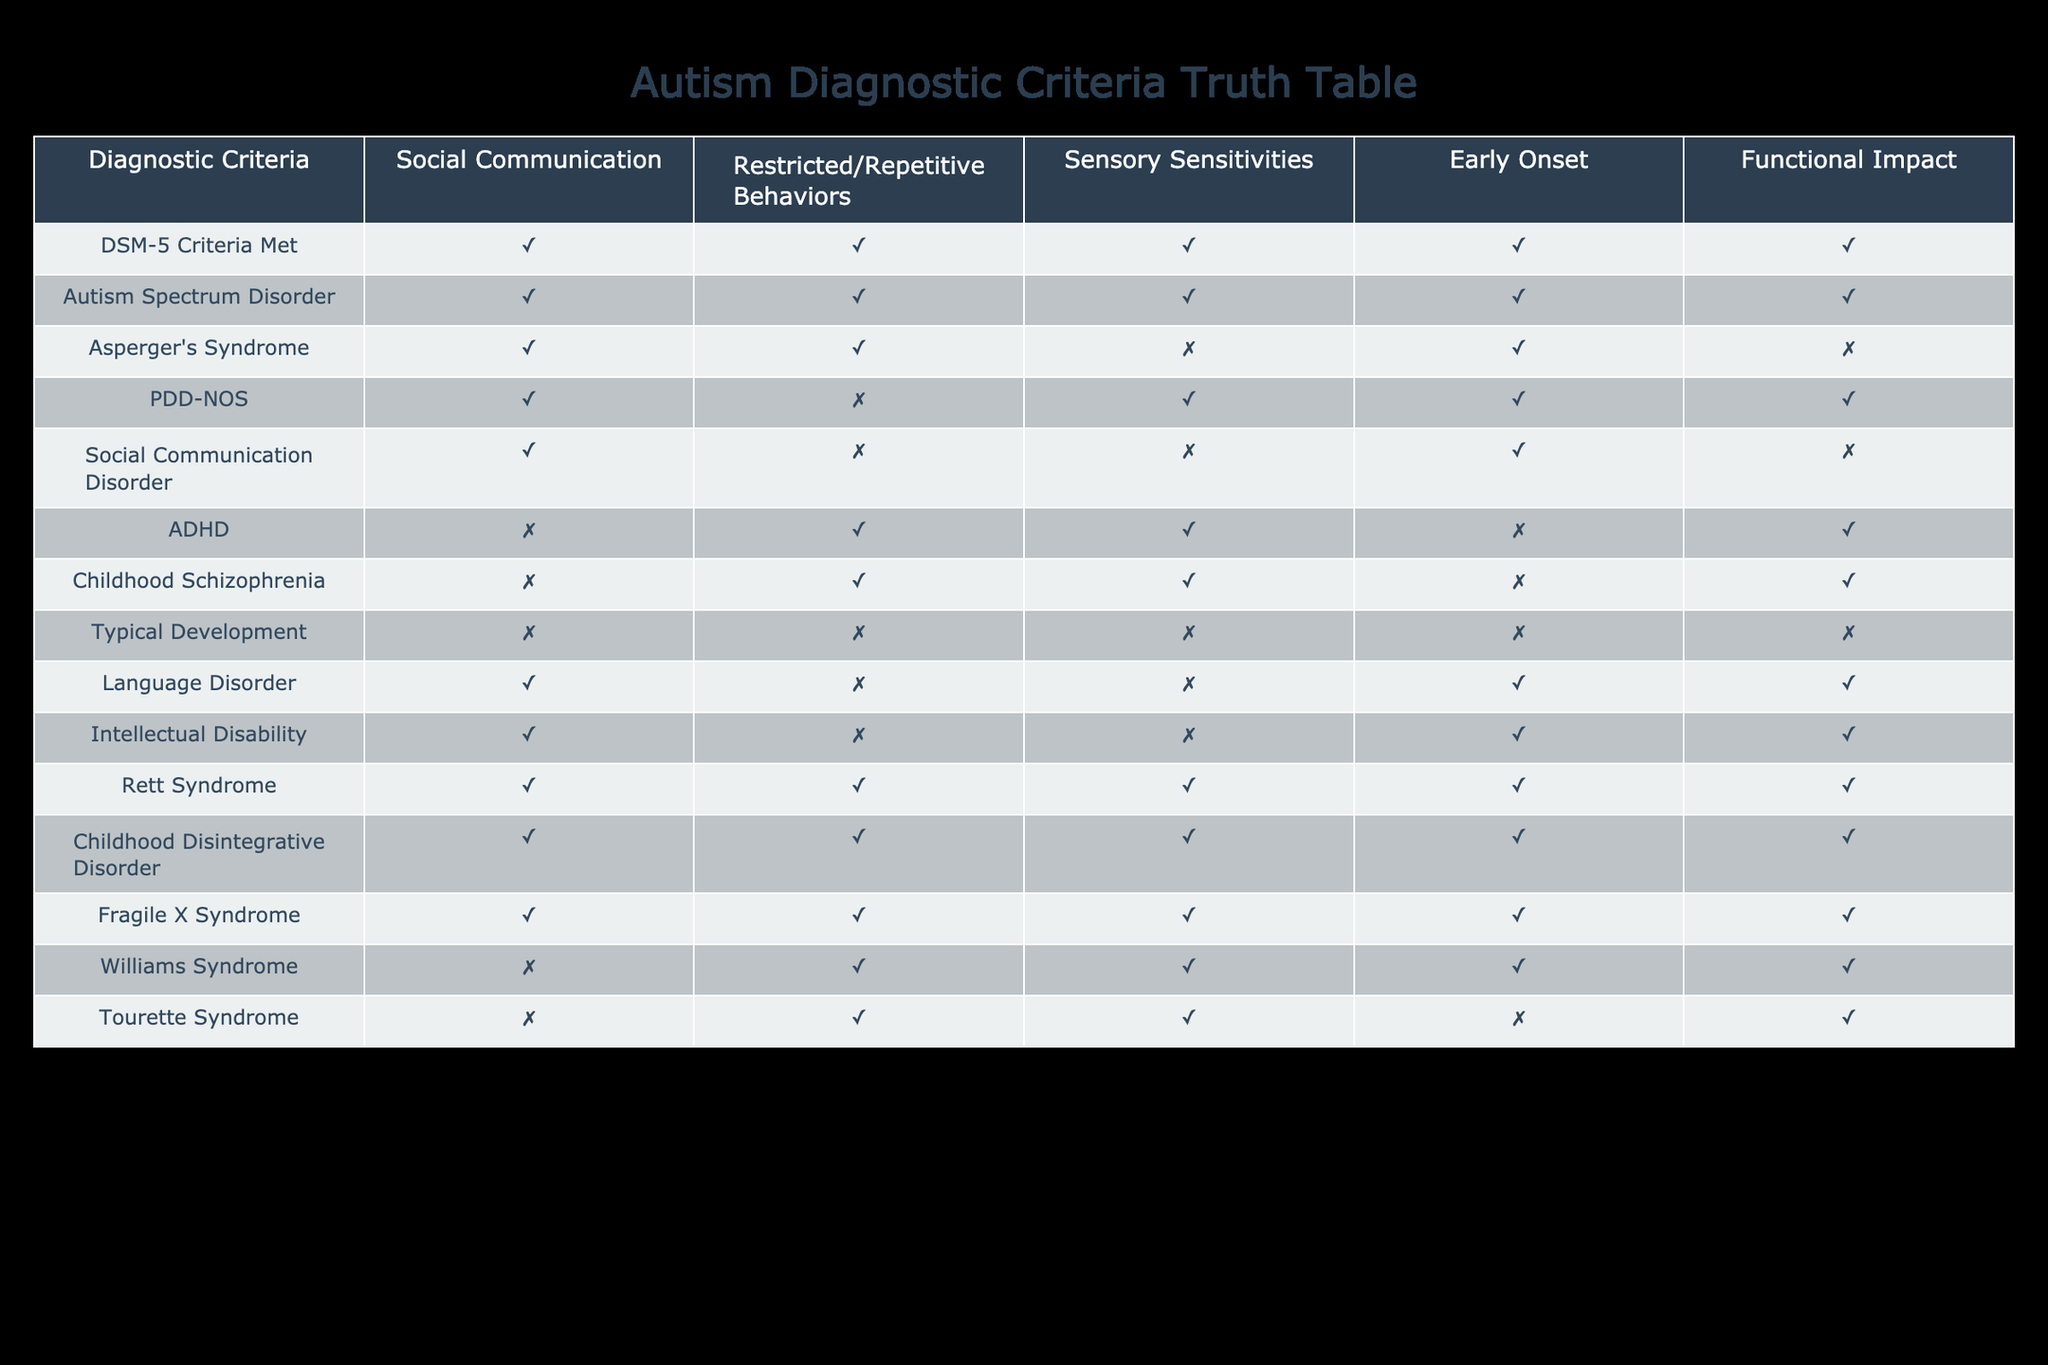What diagnostic criteria are met by Asperger's Syndrome? According to the table, Asperger's Syndrome meets the criteria for social communication and restricted/repetitive behaviors but does not meet the criteria for sensory sensitivities. Therefore, the criteria met are: Social Communication = TRUE, Restricted/Repetitive Behaviors = TRUE, Sensory Sensitivities = FALSE, Early Onset = TRUE, Functional Impact = FALSE.
Answer: Social Communication = TRUE, Restricted/Repetitive Behaviors = TRUE, Sensory Sensitivities = FALSE, Early Onset = TRUE, Functional Impact = FALSE Which conditions indicate the presence of both social communication and restricted/repetitive behaviors? By reviewing the table, several conditions have TRUE values for both social communication and restricted/repetitive behaviors. These conditions include DSM-5 Criteria Met, Autism Spectrum Disorder, Asperger's Syndrome, Rett Syndrome, Childhood Disintegrative Disorder, and Fragile X Syndrome.
Answer: DSM-5 Criteria Met, Autism Spectrum Disorder, Asperger's Syndrome, Rett Syndrome, Childhood Disintegrative Disorder, Fragile X Syndrome What is the total number of conditions that have sensory sensitivities marked as TRUE? Looking at the table, the conditions with sensory sensitivities marked as TRUE are Autism Spectrum Disorder, Asperger's Syndrome, PDD-NOS, ADHD, Childhood Schizophrenia, Rett Syndrome, Childhood Disintegrative Disorder, and Fragile X Syndrome. Counting these gives a total of 8 conditions.
Answer: 8 Is Social Communication Disorder classified under a diagnosis that meets the functional impact criteria? The table shows that Social Communication Disorder has a FALSE value for functional impact, meaning it does not meet this criteria. Therefore, Social Communication Disorder does not fall under a diagnosis with a functional impact marked as TRUE.
Answer: No Which diagnoses were present at an early age but did not show functional impact? The diagnoses that have TRUE for Early Onset but FALSE for Functional Impact are Asperger's Syndrome and PDD-NOS, as indicated in the table. Therefore, these two conditions were identified early but do not indicate a functional impact.
Answer: Asperger's Syndrome, PDD-NOS 